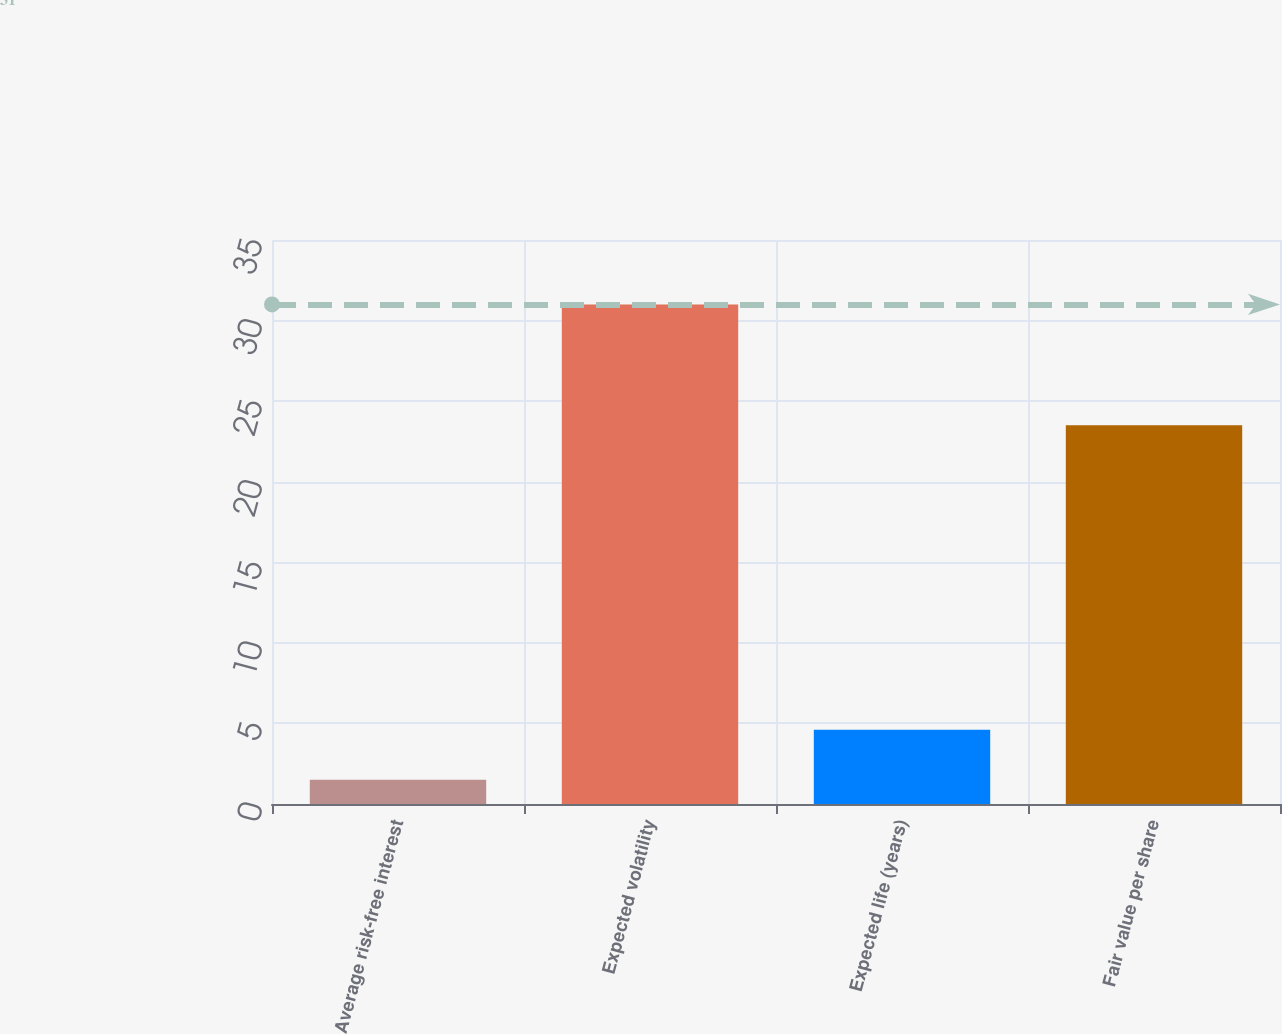<chart> <loc_0><loc_0><loc_500><loc_500><bar_chart><fcel>Average risk-free interest<fcel>Expected volatility<fcel>Expected life (years)<fcel>Fair value per share<nl><fcel>1.5<fcel>31<fcel>4.6<fcel>23.5<nl></chart> 